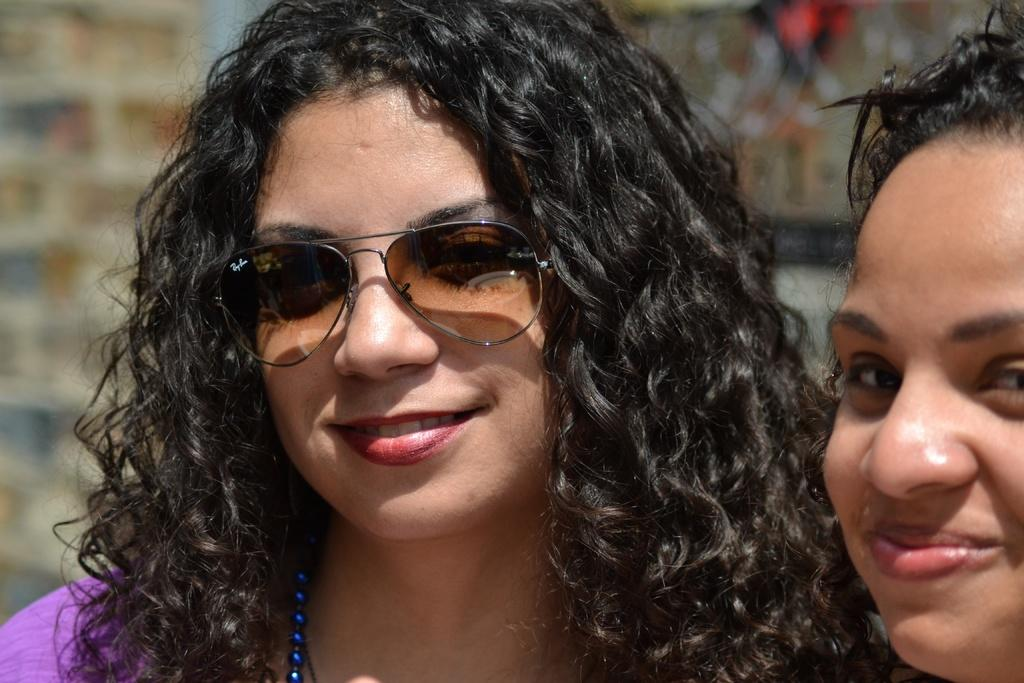Who is the main subject in the image? There is a woman in the middle of the image. What is the woman wearing on her face? The woman is wearing sunglasses. What type of accessory is the woman wearing around her neck? The woman is wearing a blue color necklace. Can you describe the other woman in the image? There is another woman on the right side of the image, and she is smiling. What type of plantation can be seen in the background of the image? There is no plantation visible in the image; it features two women. What is the woman's reaction to the shocking event in the image? There is no shocking event or reaction mentioned in the image; the women are simply standing and smiling. 